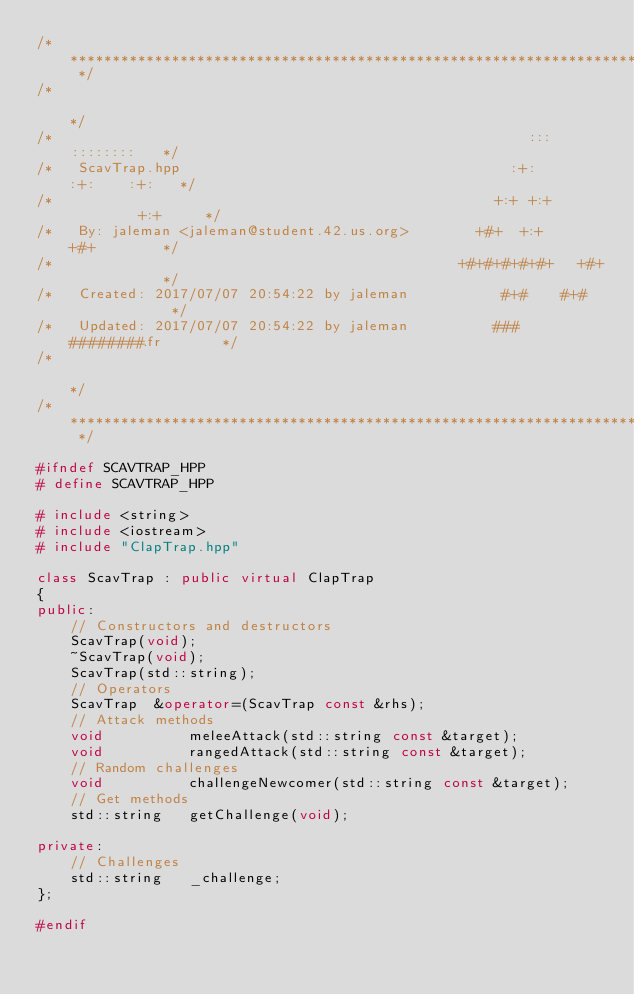<code> <loc_0><loc_0><loc_500><loc_500><_C++_>/* ************************************************************************** */
/*                                                                            */
/*                                                        :::      ::::::::   */
/*   ScavTrap.hpp                                       :+:      :+:    :+:   */
/*                                                    +:+ +:+         +:+     */
/*   By: jaleman <jaleman@student.42.us.org>        +#+  +:+       +#+        */
/*                                                +#+#+#+#+#+   +#+           */
/*   Created: 2017/07/07 20:54:22 by jaleman           #+#    #+#             */
/*   Updated: 2017/07/07 20:54:22 by jaleman          ###   ########.fr       */
/*                                                                            */
/* ************************************************************************** */

#ifndef SCAVTRAP_HPP
# define SCAVTRAP_HPP

# include <string>
# include <iostream>
# include "ClapTrap.hpp"

class ScavTrap : public virtual ClapTrap
{
public:
    // Constructors and destructors
    ScavTrap(void);
    ~ScavTrap(void);
    ScavTrap(std::string);
    // Operators
    ScavTrap  &operator=(ScavTrap const &rhs);
	// Attack methods
	void          meleeAttack(std::string const &target);
	void          rangedAttack(std::string const &target);
    // Random challenges
    void          challengeNewcomer(std::string const &target);
    // Get methods
    std::string   getChallenge(void);

private:
    // Challenges
    std::string   _challenge;
};

#endif
</code> 